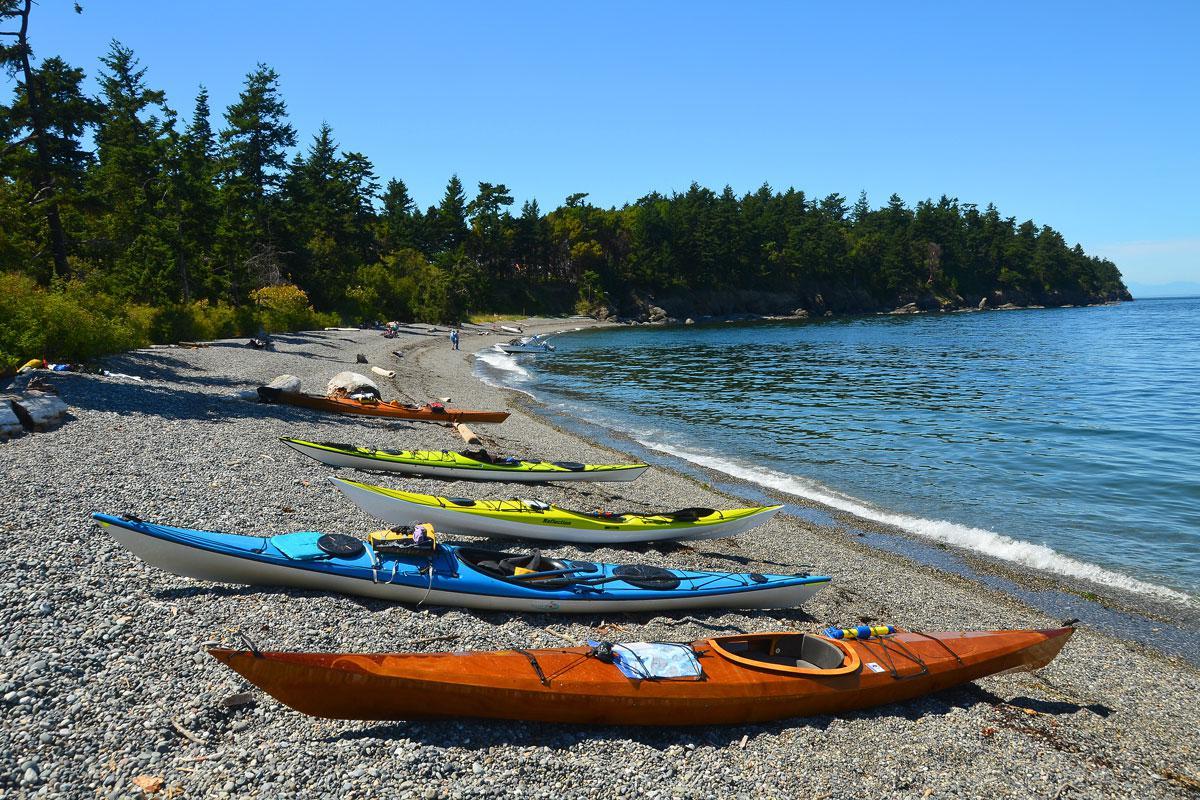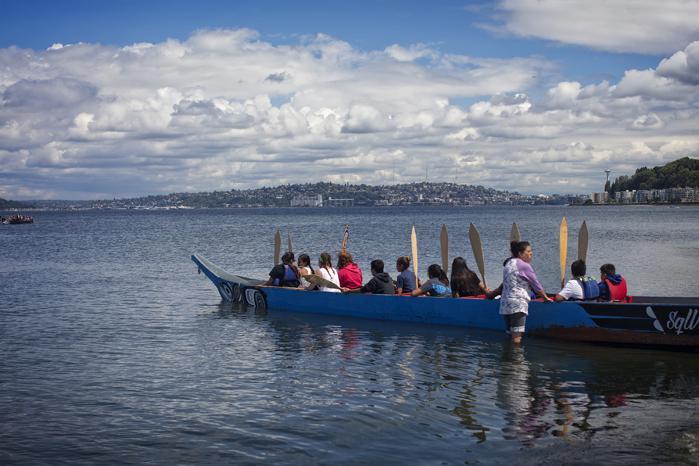The first image is the image on the left, the second image is the image on the right. Examine the images to the left and right. Is the description "There is a single man paddling a kayak in the left image." accurate? Answer yes or no. No. The first image is the image on the left, the second image is the image on the right. Assess this claim about the two images: "An image shows a single boat, which has at least four rowers.". Correct or not? Answer yes or no. Yes. 